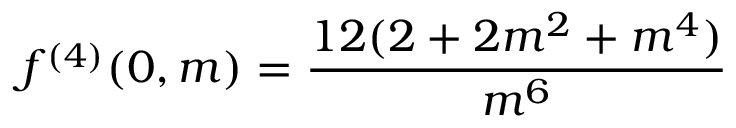<formula> <loc_0><loc_0><loc_500><loc_500>f ^ { ( 4 ) } ( 0 , m ) = \frac { 1 2 ( 2 + 2 m ^ { 2 } + m ^ { 4 } ) } { m ^ { 6 } }</formula> 